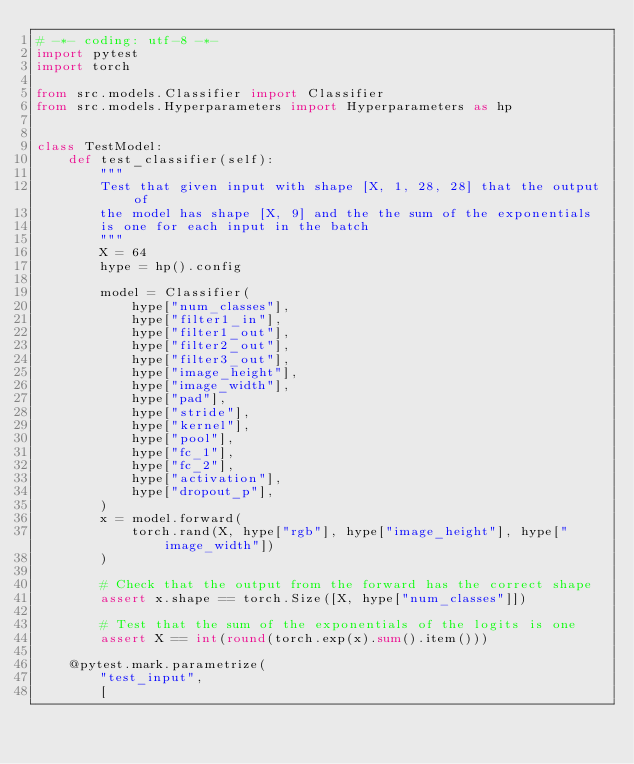<code> <loc_0><loc_0><loc_500><loc_500><_Python_># -*- coding: utf-8 -*-
import pytest
import torch

from src.models.Classifier import Classifier
from src.models.Hyperparameters import Hyperparameters as hp


class TestModel:
    def test_classifier(self):
        """
        Test that given input with shape [X, 1, 28, 28] that the output of
        the model has shape [X, 9] and the the sum of the exponentials
        is one for each input in the batch
        """
        X = 64
        hype = hp().config

        model = Classifier(
            hype["num_classes"],
            hype["filter1_in"],
            hype["filter1_out"],
            hype["filter2_out"],
            hype["filter3_out"],
            hype["image_height"],
            hype["image_width"],
            hype["pad"],
            hype["stride"],
            hype["kernel"],
            hype["pool"],
            hype["fc_1"],
            hype["fc_2"],
            hype["activation"],
            hype["dropout_p"],
        )
        x = model.forward(
            torch.rand(X, hype["rgb"], hype["image_height"], hype["image_width"])
        )

        # Check that the output from the forward has the correct shape
        assert x.shape == torch.Size([X, hype["num_classes"]])

        # Test that the sum of the exponentials of the logits is one
        assert X == int(round(torch.exp(x).sum().item()))

    @pytest.mark.parametrize(
        "test_input",
        [</code> 